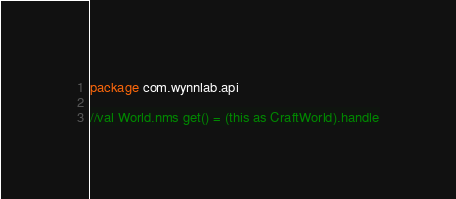Convert code to text. <code><loc_0><loc_0><loc_500><loc_500><_Kotlin_>package com.wynnlab.api

//val World.nms get() = (this as CraftWorld).handle</code> 